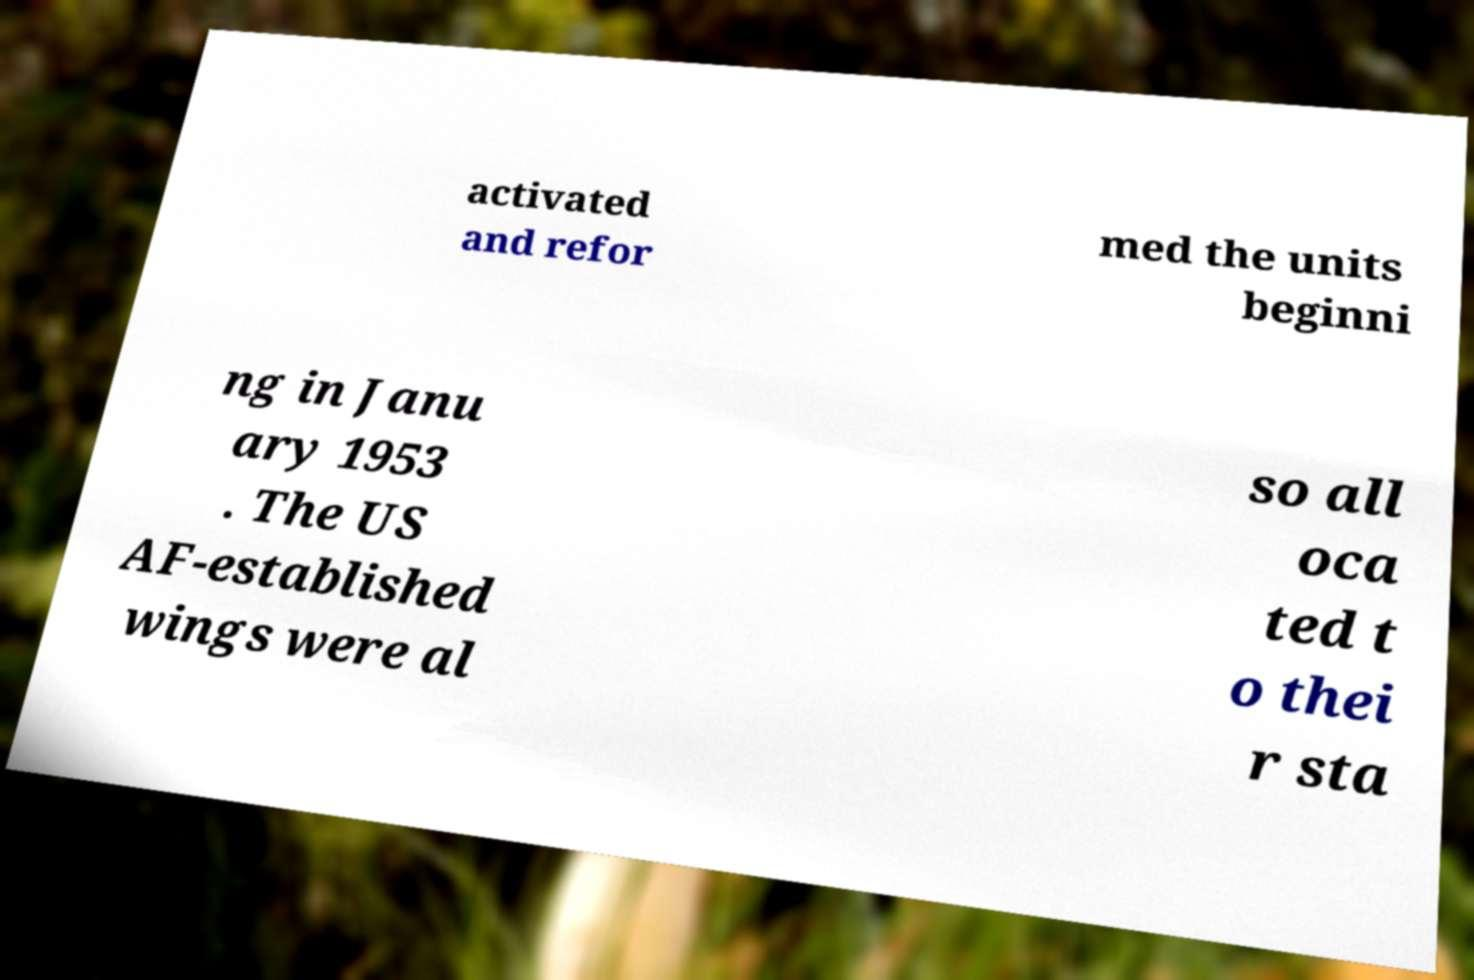What messages or text are displayed in this image? I need them in a readable, typed format. activated and refor med the units beginni ng in Janu ary 1953 . The US AF-established wings were al so all oca ted t o thei r sta 